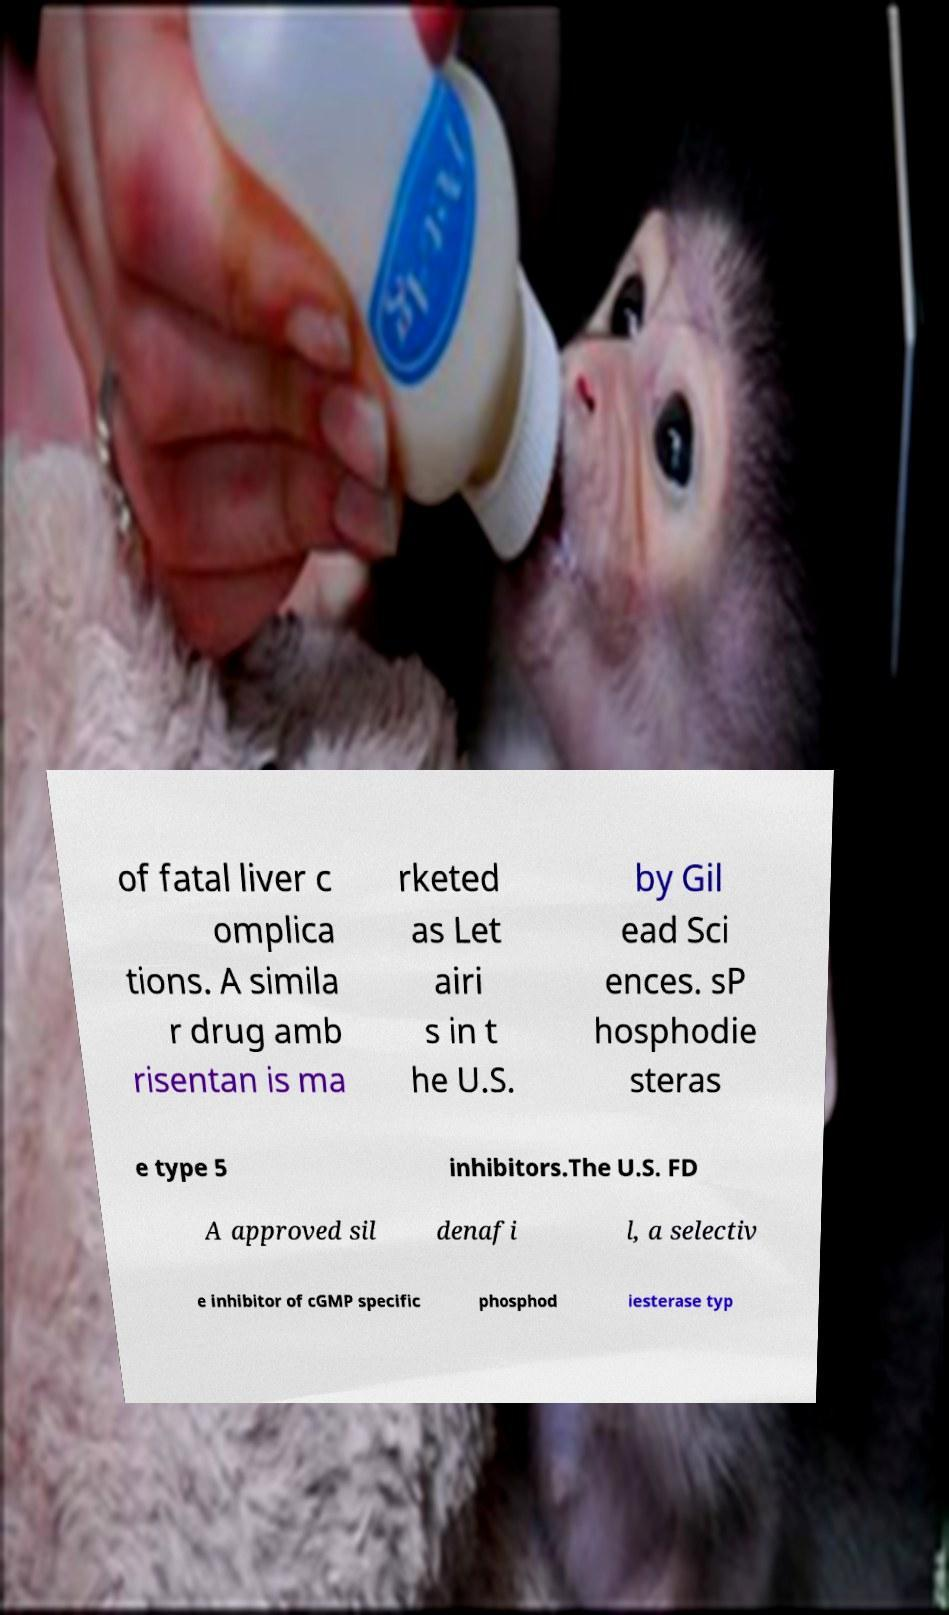Can you accurately transcribe the text from the provided image for me? of fatal liver c omplica tions. A simila r drug amb risentan is ma rketed as Let airi s in t he U.S. by Gil ead Sci ences. sP hosphodie steras e type 5 inhibitors.The U.S. FD A approved sil denafi l, a selectiv e inhibitor of cGMP specific phosphod iesterase typ 